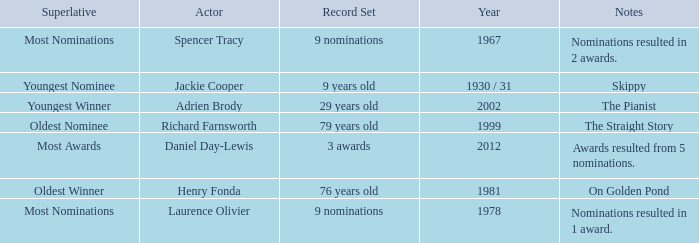What year did actor Richard Farnsworth get nominated for an award? 1999.0. 